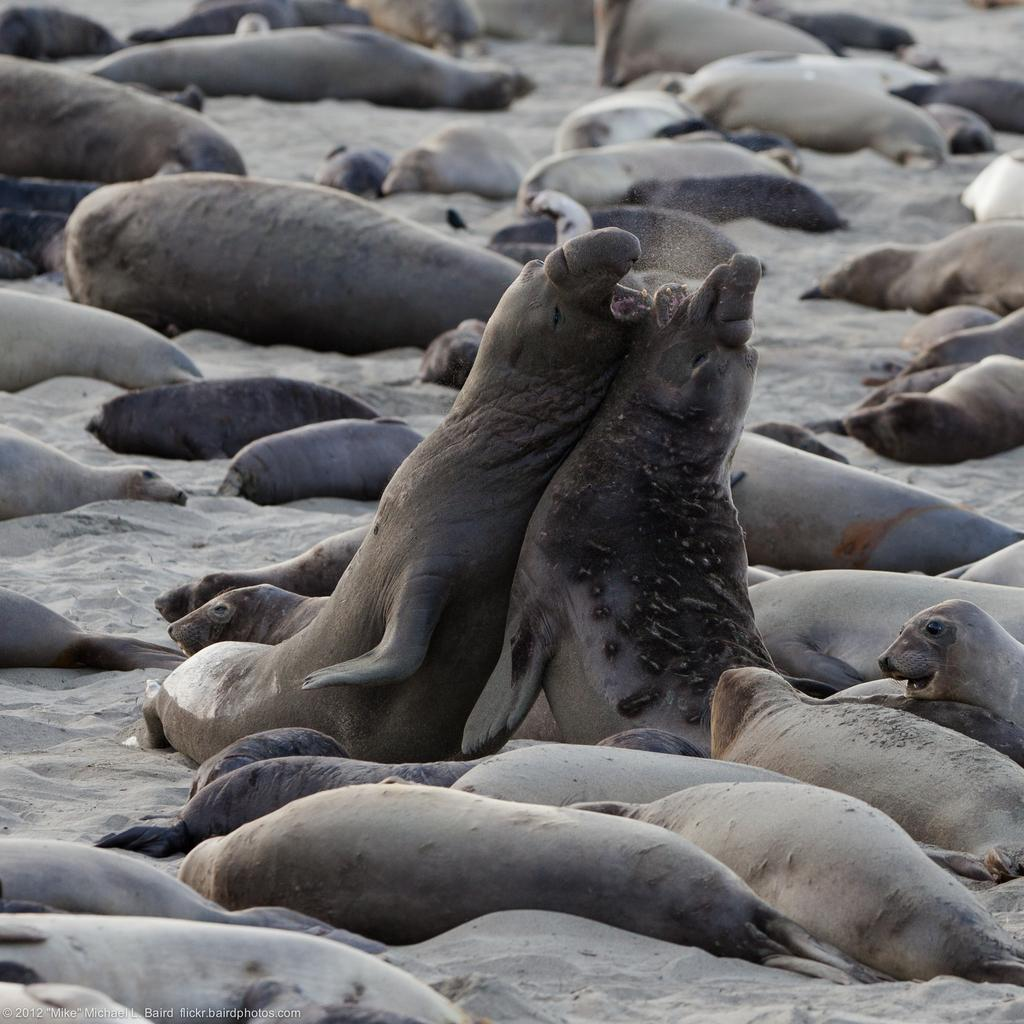What type of terrain is visible in the image? There is sand in the image. What animals can be seen in the image? There are many penguins in the image. What are the penguins doing in the image? Some penguins are sleeping, while two are fighting. What type of produce can be seen growing in the image? There is no produce visible in the image; it features sand and penguins. How many girls are present in the image? There are no girls present in the image; it features penguins. 